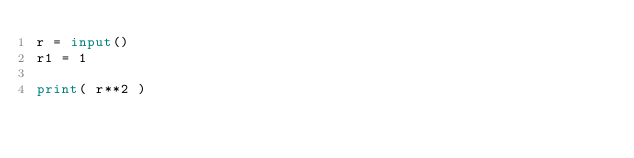<code> <loc_0><loc_0><loc_500><loc_500><_Python_>r = input()
r1 = 1

print( r**2 )</code> 